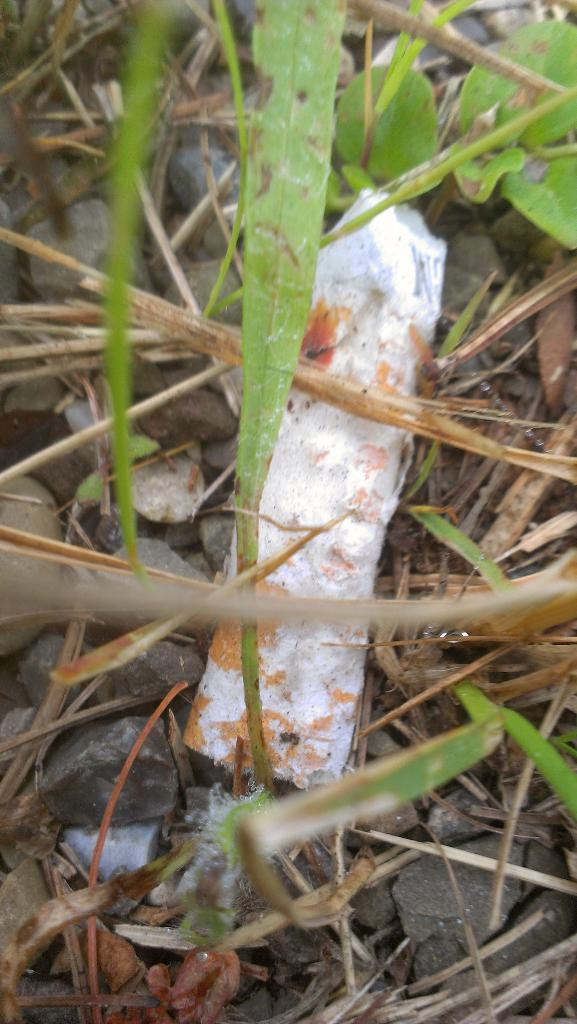What type of vegetation is present in the image? There is grass in the image. What other objects can be seen in the image besides the grass? There are stones in the image. Can you describe the white color object in the image? There is a white color object in the image, but its specific nature is not mentioned in the facts. What type of waste can be seen in the image? There is no mention of waste in the image, so we cannot determine if any waste is present. What sound can be heard coming from the white color object in the image? The facts provided do not mention any sounds or audio information, so we cannot determine if any sound is associated with the white color object. 